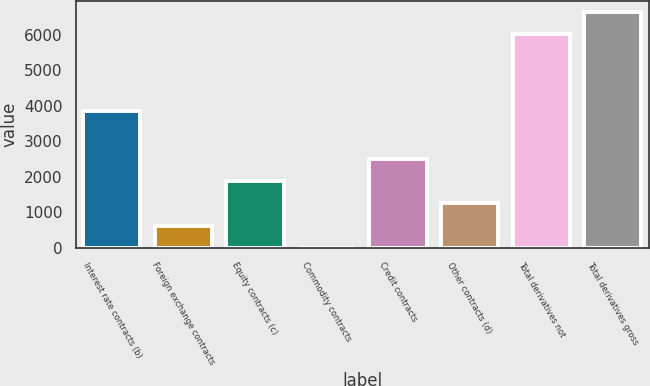<chart> <loc_0><loc_0><loc_500><loc_500><bar_chart><fcel>Interest rate contracts (b)<fcel>Foreign exchange contracts<fcel>Equity contracts (c)<fcel>Commodity contracts<fcel>Credit contracts<fcel>Other contracts (d)<fcel>Total derivatives not<fcel>Total derivatives gross<nl><fcel>3849<fcel>625.9<fcel>1867.7<fcel>5<fcel>2488.6<fcel>1246.8<fcel>6009<fcel>6629.9<nl></chart> 